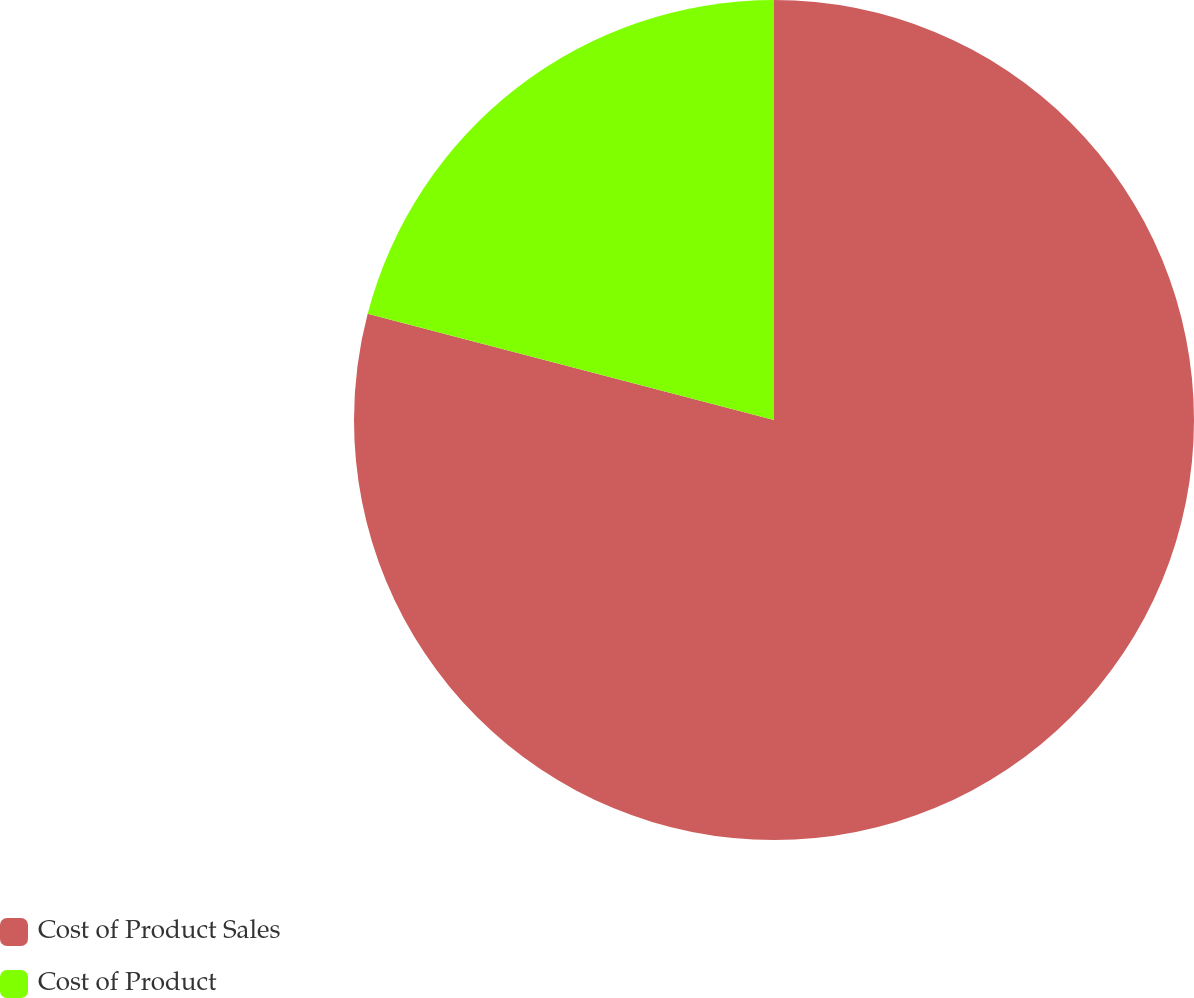<chart> <loc_0><loc_0><loc_500><loc_500><pie_chart><fcel>Cost of Product Sales<fcel>Cost of Product<nl><fcel>79.07%<fcel>20.93%<nl></chart> 